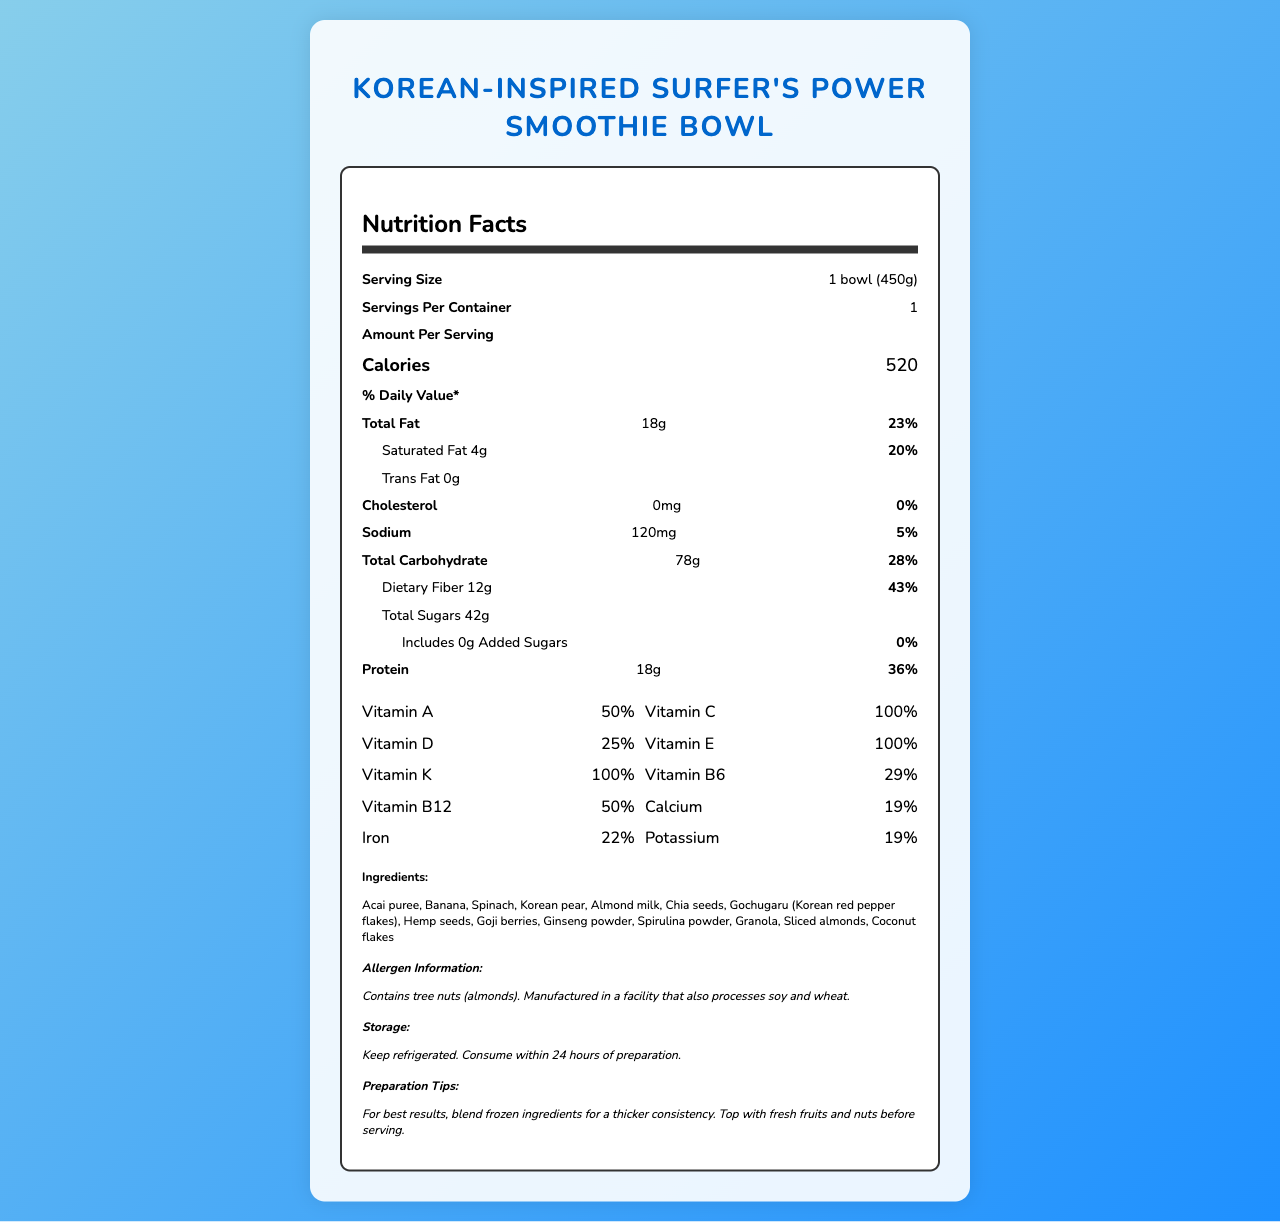How many grams of fiber are in one serving of the Korean-Inspired Surfer's Power Smoothie Bowl? The document lists dietary fiber under the total carbohydrate section with an amount of 12g per serving.
Answer: 12g What percentage of the daily value for Vitamin C is in the smoothie bowl? The document lists Vitamin C in the vitamins section with a daily value of 100%.
Answer: 100% What are the ingredients of the smoothie bowl? The document lists the ingredients under the 'Ingredients' section.
Answer: Acai puree, Banana, Spinach, Korean pear, Almond milk, Chia seeds, Gochugaru (Korean red pepper flakes), Hemp seeds, Goji berries, Ginseng powder, Spirulina powder, Granola, Sliced almonds, Coconut flakes How much iron is in the smoothie bowl? The document lists iron in the vitamins section with an amount of 4mg.
Answer: 4mg Is there any cholesterol in the smoothie bowl? The document explicitly mentions that the cholesterol amount is 0mg and the daily value is 0%.
Answer: No What is the total amount of protein per serving? A. 10g B. 18g C. 24g D. 36g The document lists protein under the amount per serving section with an amount of 18g per serving.
Answer: B. 18g What is the sodium content per serving? A. 50mg B. 120mg C. 200mg D. 300mg The document lists sodium under the total sodium section with an amount of 120mg per serving.
Answer: B. 120mg Does the smoothie bowl contain any tree nuts? The document includes an allergen information section that specifies it contains tree nuts (almonds).
Answer: Yes How should you store the smoothie bowl? The document contains storage instructions specifying to keep it refrigerated and consume within 24 hours of preparation.
Answer: Keep refrigerated. Consume within 24 hours of preparation. What is the total added sugars in the smoothie bowl? The document states that the total added sugars is 0g and lists 0% as the daily value.
Answer: 0g Summarize the main idea of the document. The main idea is conveyed through organized sections covering various nutritional details, ingredient list, and other relevant information about the smoothie bowl.
Answer: The document details the nutritional information of a Korean-Inspired Surfer's Power Smoothie Bowl, providing insights on serving size, calories, macronutrients, vitamins, minerals, ingredients, allergen info, storage instructions, and preparation tips. How does the preparation tips section suggest achieving a thicker consistency? The preparation tips section advises blending frozen ingredients for a thicker consistency.
Answer: Blend frozen ingredients What is the highest daily value percentage listed for any vitamin or mineral? Both Vitamin C, Vitamin E, Vitamin K, and Biotin are listed with a daily value percentage of 100%.
Answer: 100% How long can the smoothie bowl be consumed once prepared? The storage instructions mention to consume the smoothie bowl within 24 hours of preparation.
Answer: Within 24 hours Does the document provide information on the exact quantity of Gochugaru used in the smoothie bowl? The document lists Gochugaru as an ingredient but does not specify its exact quantity.
Answer: Not enough information 